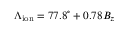Convert formula to latex. <formula><loc_0><loc_0><loc_500><loc_500>\Lambda _ { i o n } = 7 7 . 8 ^ { \circ } + 0 . 7 8 B _ { z }</formula> 